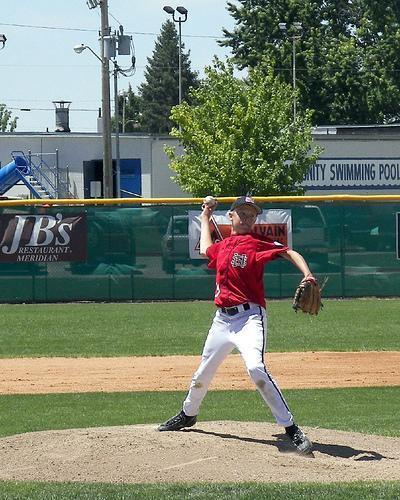How many people are there?
Give a very brief answer. 1. How many players are there?
Give a very brief answer. 1. 